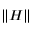<formula> <loc_0><loc_0><loc_500><loc_500>\| H \|</formula> 